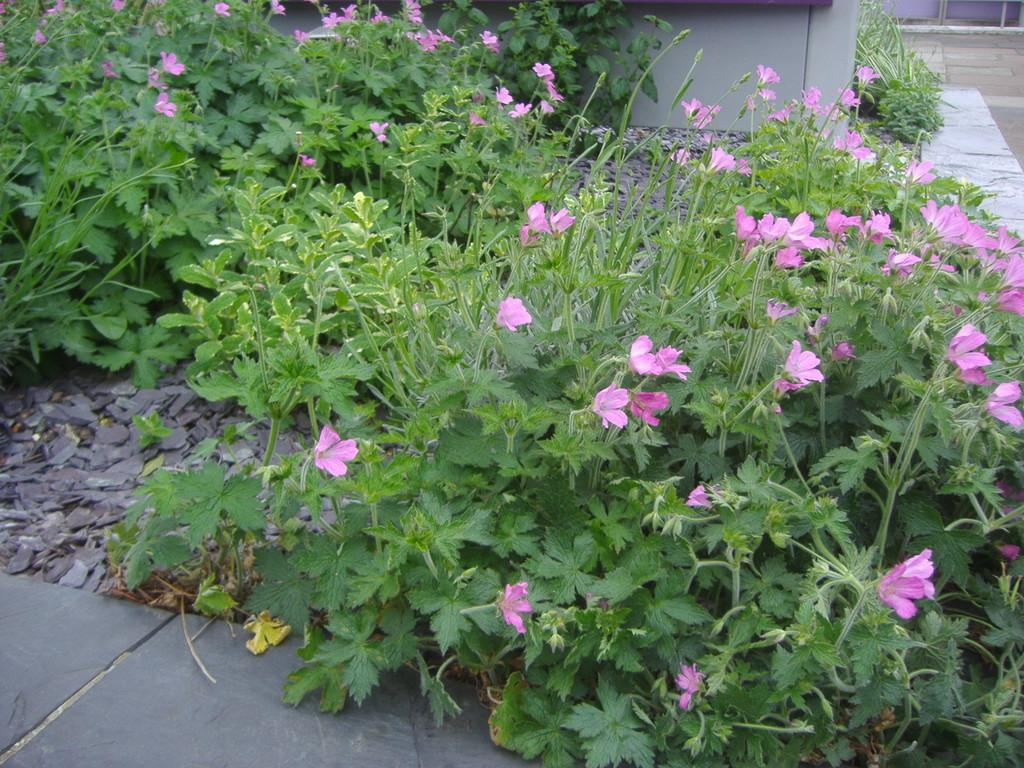What type of plants are in the image? There are pink color flower plants in the image. Where are the flower plants located? The flower plants are on the land. What can be seen at the top of the image? There is a pavement at the top of the image. Can you describe the unspecified object in the image? Unfortunately, there is not enough information provided to describe the unspecified object in the image. What language is the grandfather speaking to the shoe in the image? There is no grandfather or shoe present in the image, so this question cannot be answered. 